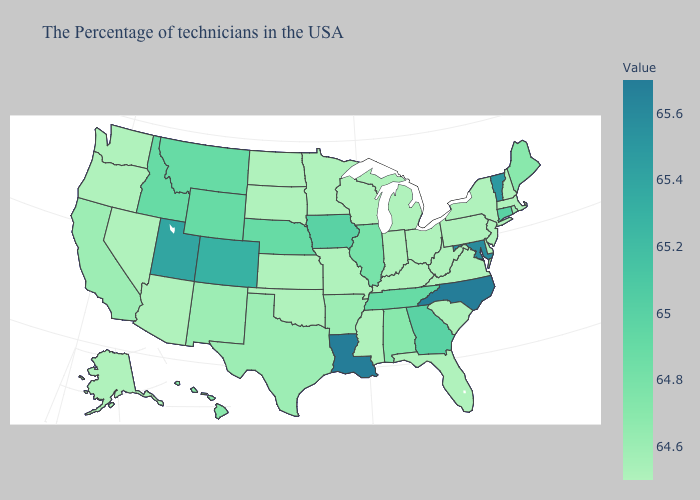Which states have the highest value in the USA?
Answer briefly. North Carolina, Louisiana. Does California have the highest value in the West?
Write a very short answer. No. Does Tennessee have a lower value than Oregon?
Concise answer only. No. Does Washington have a lower value than Connecticut?
Write a very short answer. Yes. Which states hav the highest value in the Northeast?
Keep it brief. Vermont. Among the states that border Colorado , does Arizona have the lowest value?
Give a very brief answer. Yes. Does Illinois have the lowest value in the USA?
Give a very brief answer. No. Does Illinois have the lowest value in the MidWest?
Be succinct. No. 